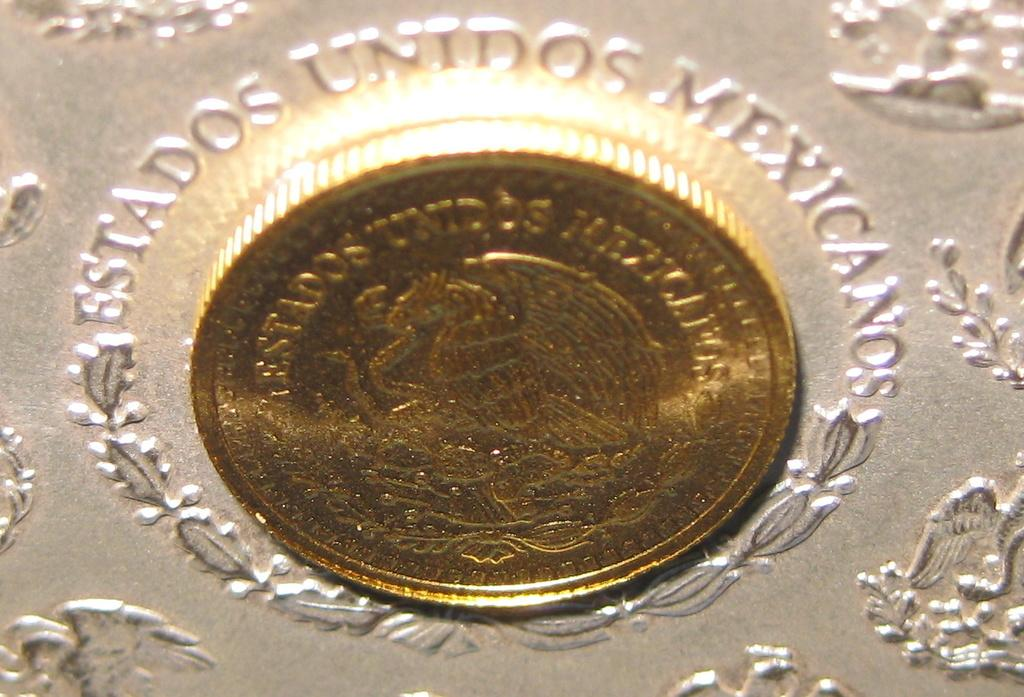What object can be seen in the image? There is a coin in the image. What else is present in the image besides the coin? There is text and a design on a platform in the image. What type of shoe is being worn by the person in the image? There is no person or shoe present in the image; it only features a coin, text, and a design on a platform. 